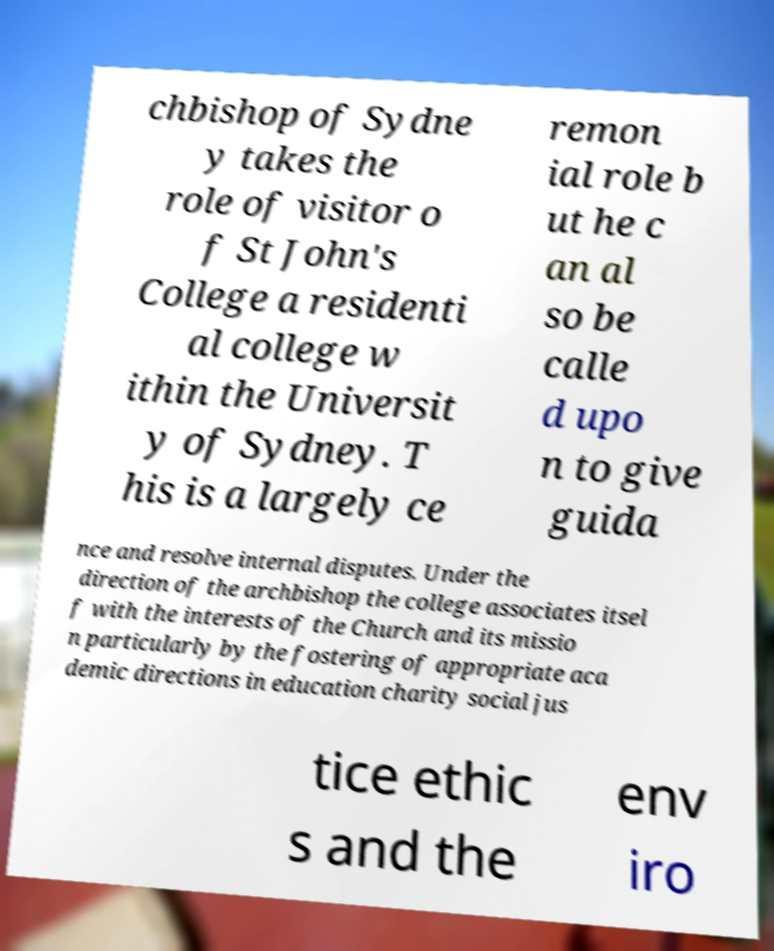Could you assist in decoding the text presented in this image and type it out clearly? chbishop of Sydne y takes the role of visitor o f St John's College a residenti al college w ithin the Universit y of Sydney. T his is a largely ce remon ial role b ut he c an al so be calle d upo n to give guida nce and resolve internal disputes. Under the direction of the archbishop the college associates itsel f with the interests of the Church and its missio n particularly by the fostering of appropriate aca demic directions in education charity social jus tice ethic s and the env iro 